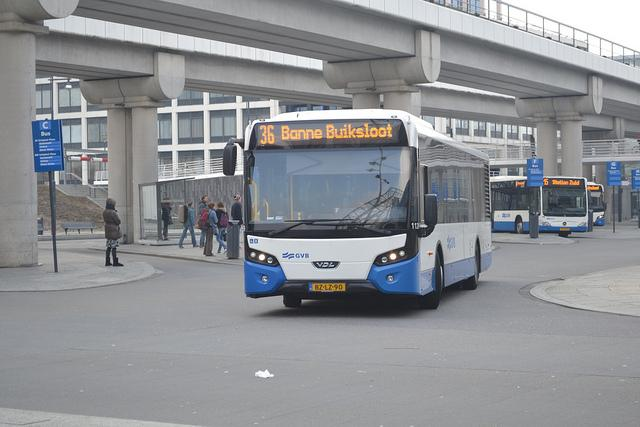Where are these people probably waiting to catch a bus?

Choices:
A) airport
B) street
C) terminal
D) underground terminal 